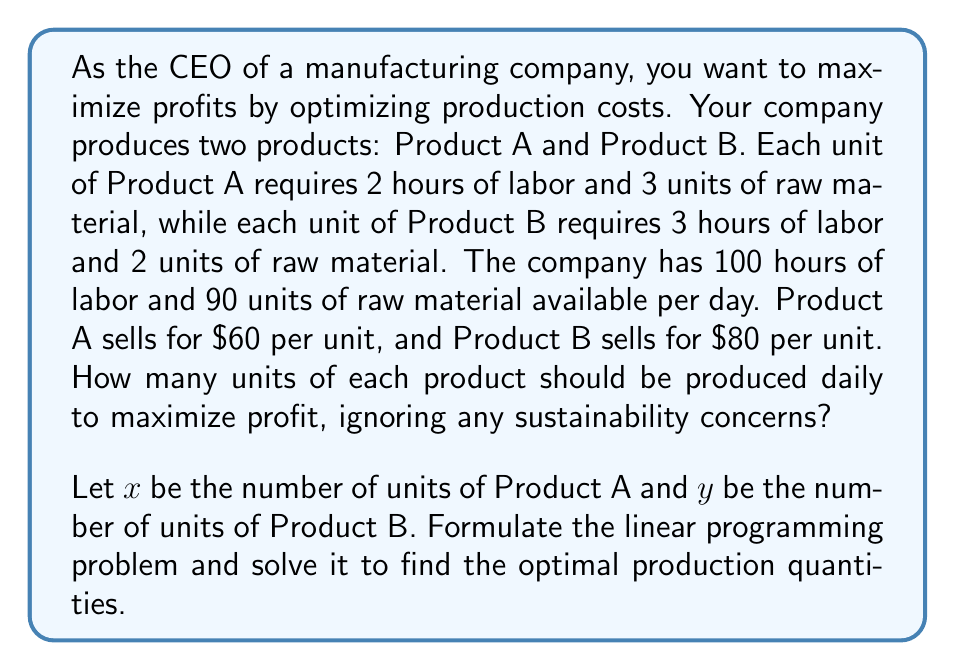Solve this math problem. Step 1: Formulate the objective function
Profit = Revenue from A + Revenue from B
$$Z = 60x + 80y$$

Step 2: Identify the constraints
Labor constraint: $2x + 3y \leq 100$
Raw material constraint: $3x + 2y \leq 90$
Non-negativity constraints: $x \geq 0$, $y \geq 0$

Step 3: Graph the constraints
[asy]
size(200);
draw((0,0)--(50,0)--(50,33.33)--(0,33.33)--cycle);
draw((0,0)--(50,0), arrow=Arrow(TeXHead));
draw((0,0)--(0,35), arrow=Arrow(TeXHead));
draw((0,33.33)--(50,0), blue);
draw((0,30)--(45,0), red);
label("x", (50,0), E);
label("y", (0,35), N);
label("2x + 3y = 100", (25,20), NW, blue);
label("3x + 2y = 90", (30,10), SE, red);
dot((30,20));
label("(30, 20)", (30,20), NE);
[/asy]

Step 4: Identify the corner points
(0,0), (0,30), (30,20), (45,0)

Step 5: Evaluate the objective function at each corner point
Z(0,0) = 0
Z(0,30) = 2400
Z(30,20) = 3400
Z(45,0) = 2700

Step 6: Determine the optimal solution
The maximum profit occurs at the point (30,20), which means producing 30 units of Product A and 20 units of Product B daily.
Answer: 30 units of Product A, 20 units of Product B 